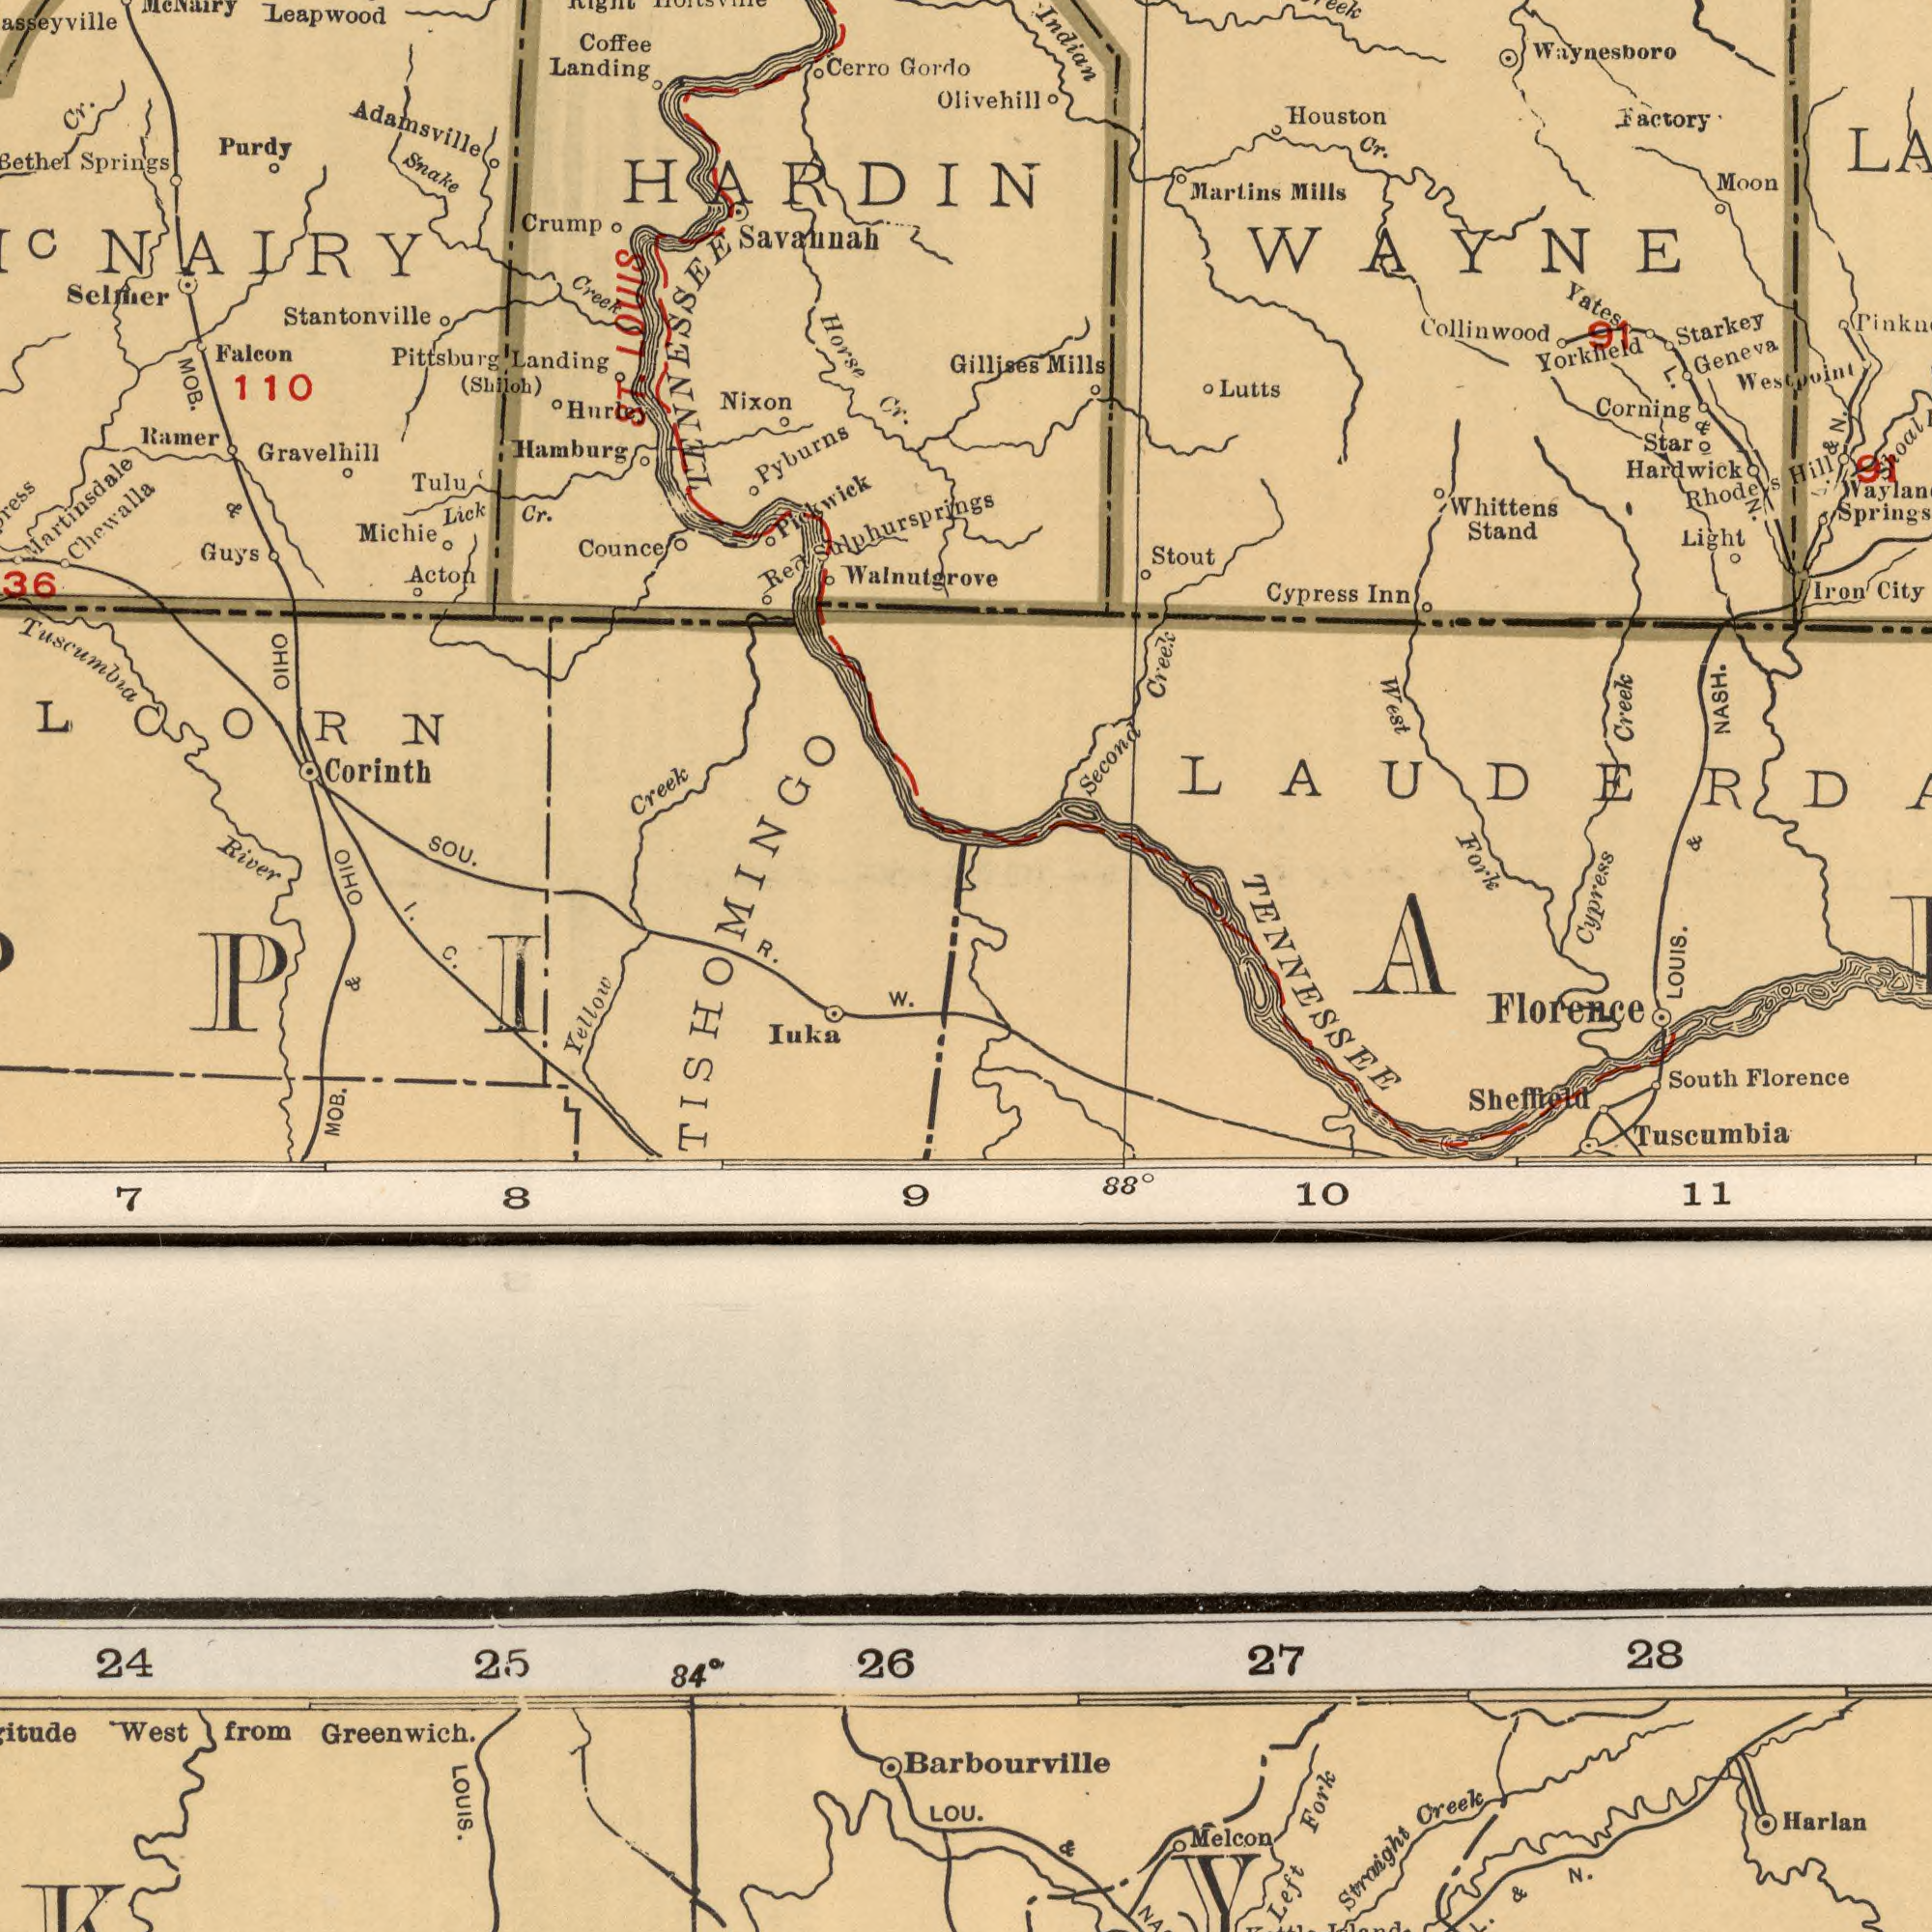What text is visible in the lower-left corner? MOB. Yellow Iuka Greenwich. from W. West 9 & 7 8 24 25 84<sup>0</sup> 26 LOUIS. LOU. What text is visible in the upper-right corner? Waynesboro Collinwood Hardwick Indian Cypress Fork Starkey Corning Yorkfield Moon City Houston Second Factory Whittens Creek Martins Mills Stout Mills Cypress Geneva Creek Stand Westpoint Lutts Yates Iron Light Cr. N. Gillises Rhodes Star Inn WAYNE L. NASH. Olivehill 91 Hill Shoal & N. L. & 91 West LOUIS. & What text can you see in the bottom-right section? Sheffield Florence Florence Straight Fork South 11 Harlan Creek Tuscumbia Left 88<sup>0</sup> 10 & TENNESSEE 27 28 Barbourville Melcon Y & N. What text is shown in the top-left quadrant? Adamsville Martinsdale Savannah Stantonville MOB. Leapwood Springs Horse R. Pyburns River Gordo Creek Counce Landing Walnutgrove Tuscumbia Cr. Nixon Hamburg Pittsburg Pickwick Tulu Cr. Purdy Landing Michie SOU. Creek Snake Falcon Crump Ramer (Shiloh) Cr. Selmer 36 Hurley Gravelhill Acton Red Coffee Cerro Lick Guys Chewalla HARDIN TENNESSEE 110 ST. LOUIS Mc Nairy NAIRY & Sulphursprings Corinth LCORN OHIO OHIO I. C. TISHOMINGO 